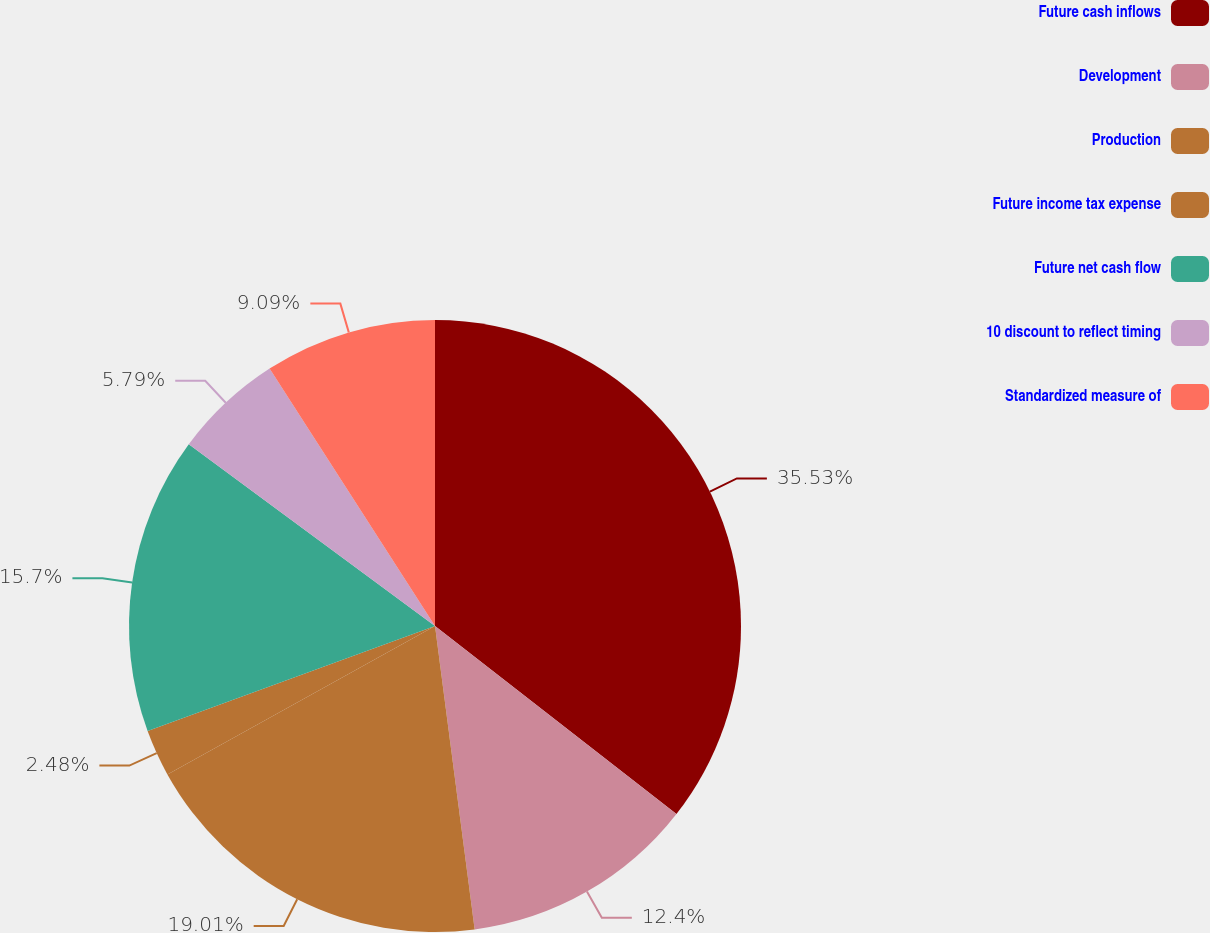<chart> <loc_0><loc_0><loc_500><loc_500><pie_chart><fcel>Future cash inflows<fcel>Development<fcel>Production<fcel>Future income tax expense<fcel>Future net cash flow<fcel>10 discount to reflect timing<fcel>Standardized measure of<nl><fcel>35.53%<fcel>12.4%<fcel>19.01%<fcel>2.48%<fcel>15.7%<fcel>5.79%<fcel>9.09%<nl></chart> 